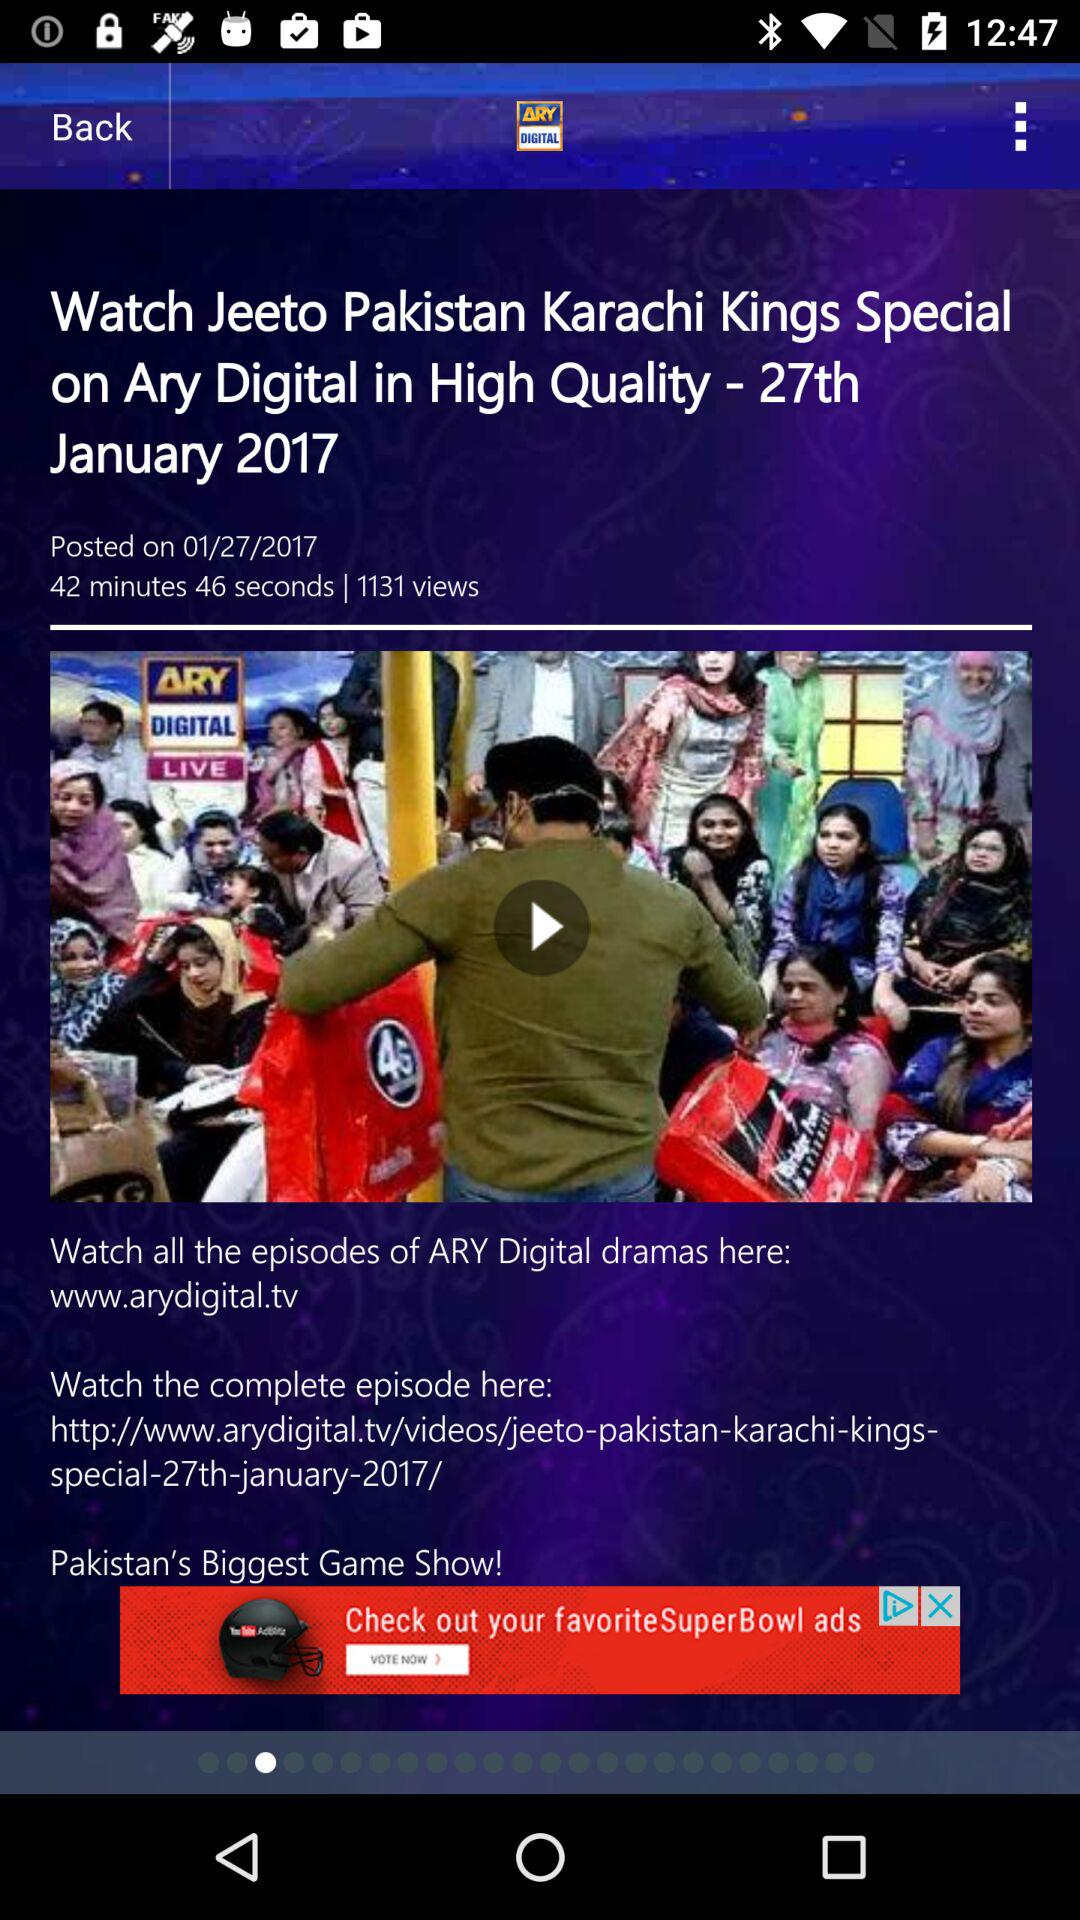When was the video posted? The video was posted on January 27, 2017. 